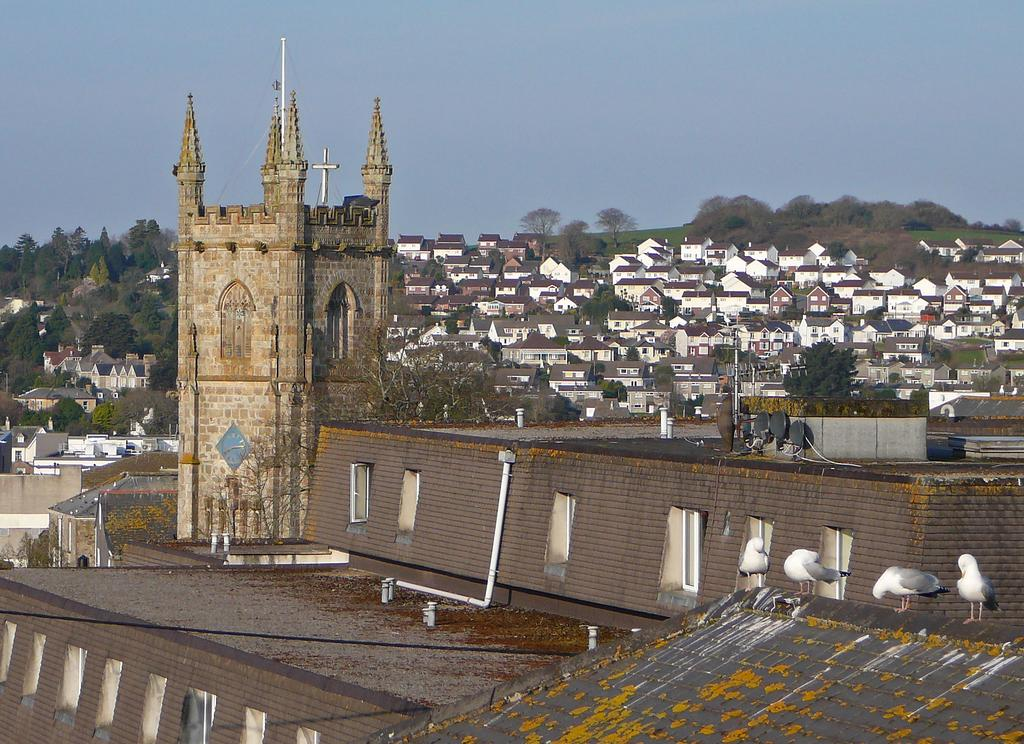What type of structures can be seen in the image? There are buildings in the image. What other natural elements are present in the image? There are trees in the image. Where are the birds located in the image? Birds are visible on the right side of the image. What can be seen in the background of the image? The sky is visible in the background of the image. What type of drug is being sold by the scarecrow in the image? There is no scarecrow or drug present in the image. How many police officers are visible in the image? There are no police officers present in the image. 